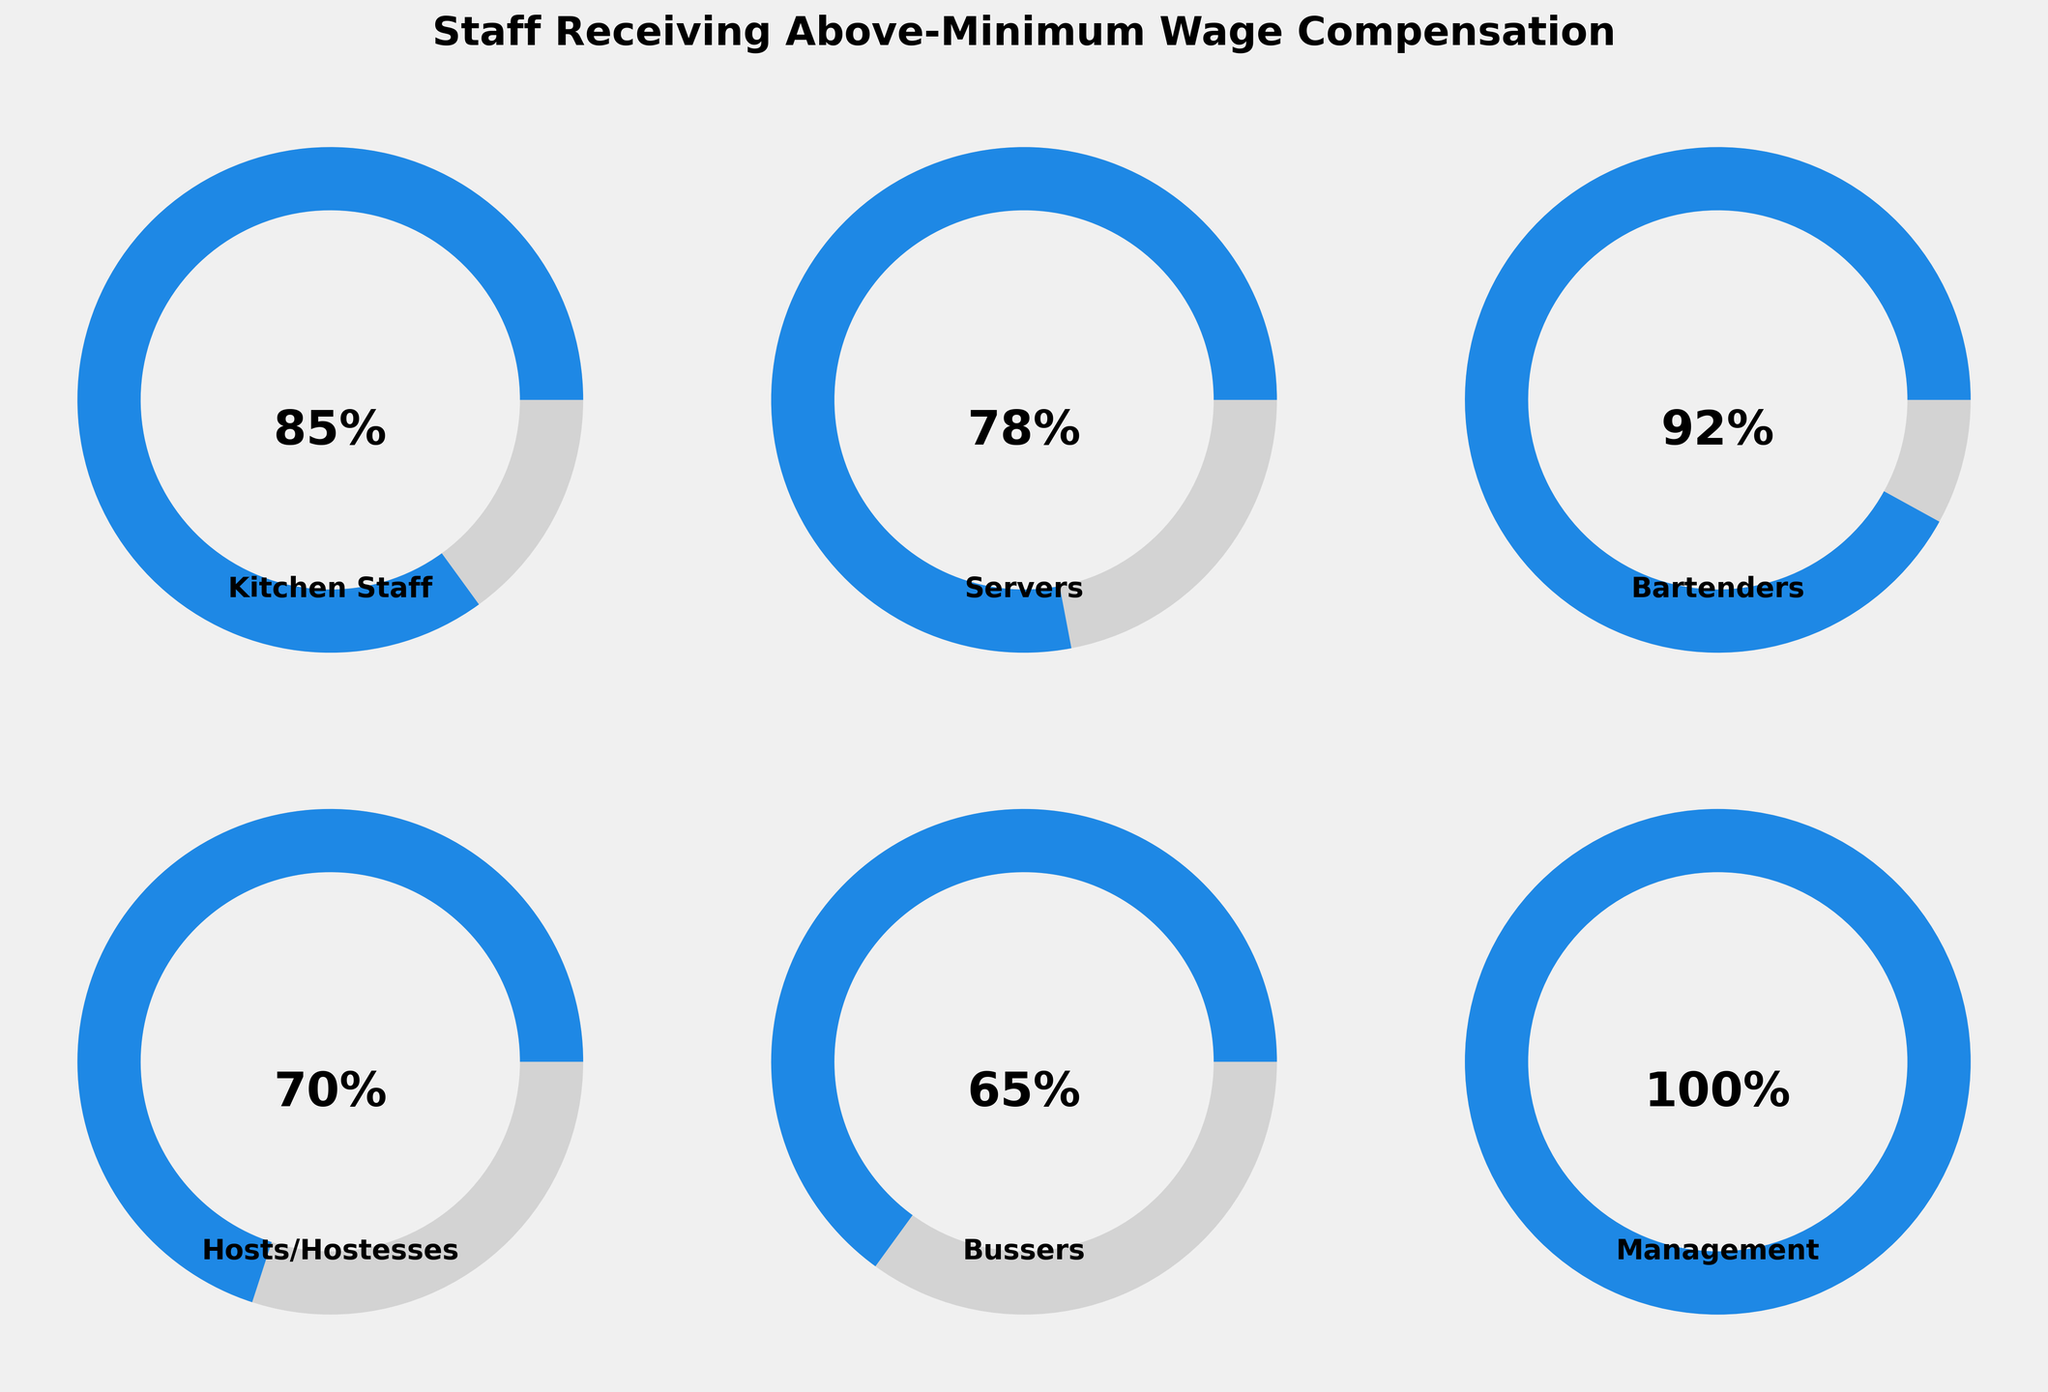What is the title of the figure? The title is typically displayed at the top of the figure. In this case, the title reads "Staff Receiving Above-Minimum Wage Compensation".
Answer: Staff Receiving Above-Minimum Wage Compensation Which category has the highest percentage of staff receiving above-minimum wage compensation? To find the category with the highest percentage, look at all the gauge charts and identify which one has the highest percentage value. The management category shows 100%.
Answer: Management Which two categories have the lowest percentage of staff receiving above-minimum wage compensation? Compare all the percentage values in each gauge chart and find the two lowest. The Host/Hostesses show 70% and Bussers show 65%.
Answer: Host/Hostesses and Bussers What is the average percentage of staff receiving above-minimum wage compensation across all categories? Add up all the percentage values and divide by the number of categories, which is 6: (85 + 78 + 92 + 70 + 65 + 100) / 6 = 490 / 6 = approximately 81.67.
Answer: 81.67 How much higher is the percentage of Bartenders compared to Hosts/Hostesses? Subtract the percentage of Hosts/Hostesses from Bartenders: 92 - 70 = 22.
Answer: 22 What is the color used to represent the filled portion of the gauges? The color of the filled portion of the gauges can be observed, and it is blue.
Answer: Blue Which category has the smallest percentage of staff receiving above-minimum wage compensation? Identify the category with the lowest percentage value. Bussers have the smallest percentage at 65%.
Answer: Bussers How many categories have more than 80% of staff receiving above-minimum wage compensation? Count the number of categories where the percentage is greater than 80. There are three: Kitchen Staff (85%), Bartenders (92%), and Management (100%).
Answer: 3 If the Kitchen Staff increased their percentage by 10%, what would their new percentage be? Add 10 to the current Kitchen Staff percentage: 85 + 10 = 95.
Answer: 95 